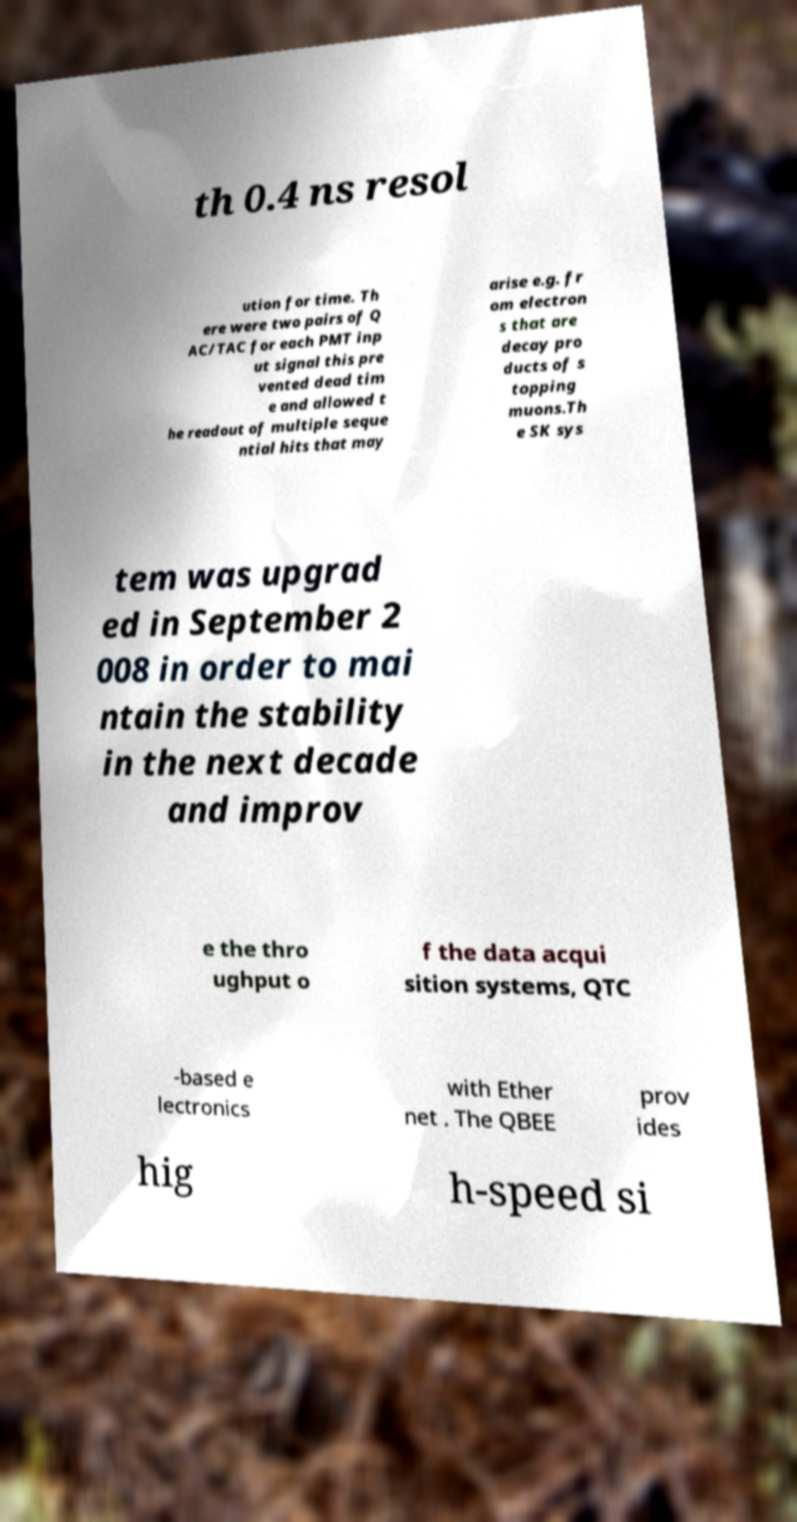Can you accurately transcribe the text from the provided image for me? th 0.4 ns resol ution for time. Th ere were two pairs of Q AC/TAC for each PMT inp ut signal this pre vented dead tim e and allowed t he readout of multiple seque ntial hits that may arise e.g. fr om electron s that are decay pro ducts of s topping muons.Th e SK sys tem was upgrad ed in September 2 008 in order to mai ntain the stability in the next decade and improv e the thro ughput o f the data acqui sition systems, QTC -based e lectronics with Ether net . The QBEE prov ides hig h-speed si 